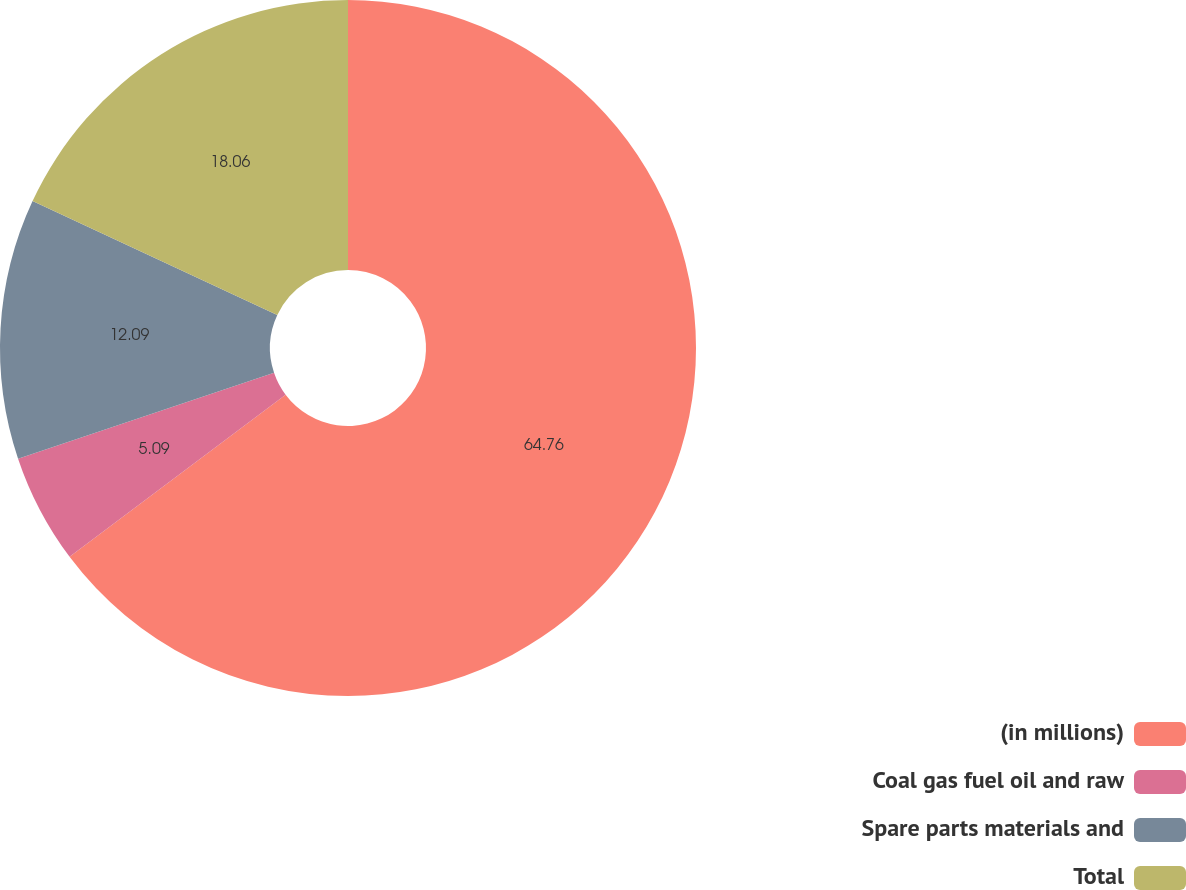<chart> <loc_0><loc_0><loc_500><loc_500><pie_chart><fcel>(in millions)<fcel>Coal gas fuel oil and raw<fcel>Spare parts materials and<fcel>Total<nl><fcel>64.76%<fcel>5.09%<fcel>12.09%<fcel>18.06%<nl></chart> 